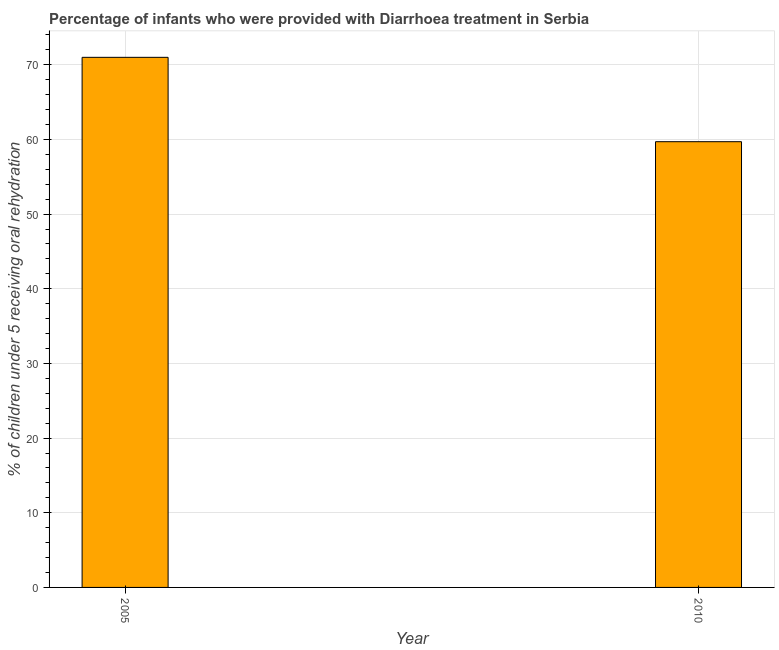Does the graph contain any zero values?
Provide a short and direct response. No. What is the title of the graph?
Give a very brief answer. Percentage of infants who were provided with Diarrhoea treatment in Serbia. What is the label or title of the X-axis?
Offer a very short reply. Year. What is the label or title of the Y-axis?
Offer a very short reply. % of children under 5 receiving oral rehydration. What is the percentage of children who were provided with treatment diarrhoea in 2005?
Provide a succinct answer. 71. Across all years, what is the maximum percentage of children who were provided with treatment diarrhoea?
Provide a succinct answer. 71. Across all years, what is the minimum percentage of children who were provided with treatment diarrhoea?
Ensure brevity in your answer.  59.7. In which year was the percentage of children who were provided with treatment diarrhoea maximum?
Provide a succinct answer. 2005. What is the sum of the percentage of children who were provided with treatment diarrhoea?
Provide a succinct answer. 130.7. What is the difference between the percentage of children who were provided with treatment diarrhoea in 2005 and 2010?
Provide a short and direct response. 11.3. What is the average percentage of children who were provided with treatment diarrhoea per year?
Offer a very short reply. 65.35. What is the median percentage of children who were provided with treatment diarrhoea?
Provide a succinct answer. 65.35. In how many years, is the percentage of children who were provided with treatment diarrhoea greater than 16 %?
Give a very brief answer. 2. What is the ratio of the percentage of children who were provided with treatment diarrhoea in 2005 to that in 2010?
Give a very brief answer. 1.19. Is the percentage of children who were provided with treatment diarrhoea in 2005 less than that in 2010?
Make the answer very short. No. In how many years, is the percentage of children who were provided with treatment diarrhoea greater than the average percentage of children who were provided with treatment diarrhoea taken over all years?
Your answer should be compact. 1. What is the difference between two consecutive major ticks on the Y-axis?
Make the answer very short. 10. Are the values on the major ticks of Y-axis written in scientific E-notation?
Offer a very short reply. No. What is the % of children under 5 receiving oral rehydration in 2010?
Your answer should be compact. 59.7. What is the ratio of the % of children under 5 receiving oral rehydration in 2005 to that in 2010?
Ensure brevity in your answer.  1.19. 